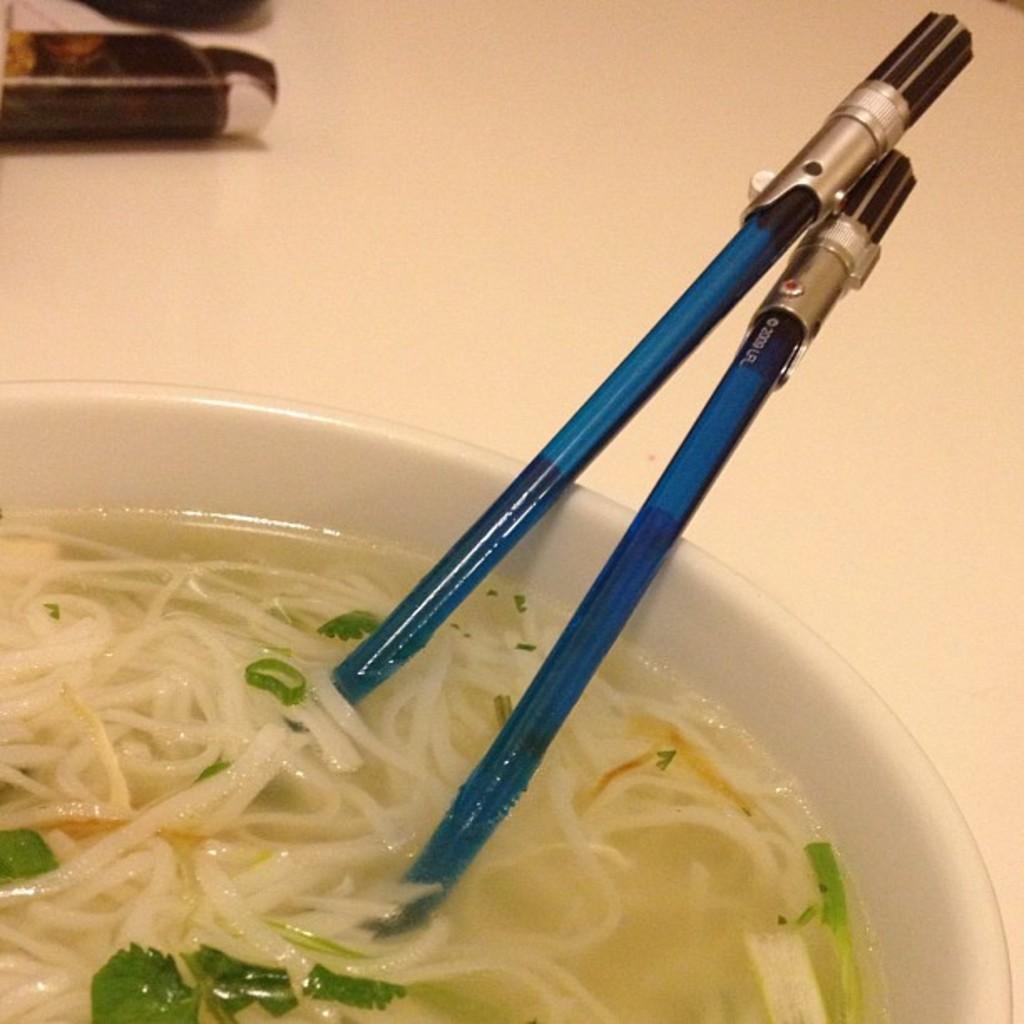In one or two sentences, can you explain what this image depicts? In this there is food inside the bowl with two spoons. 